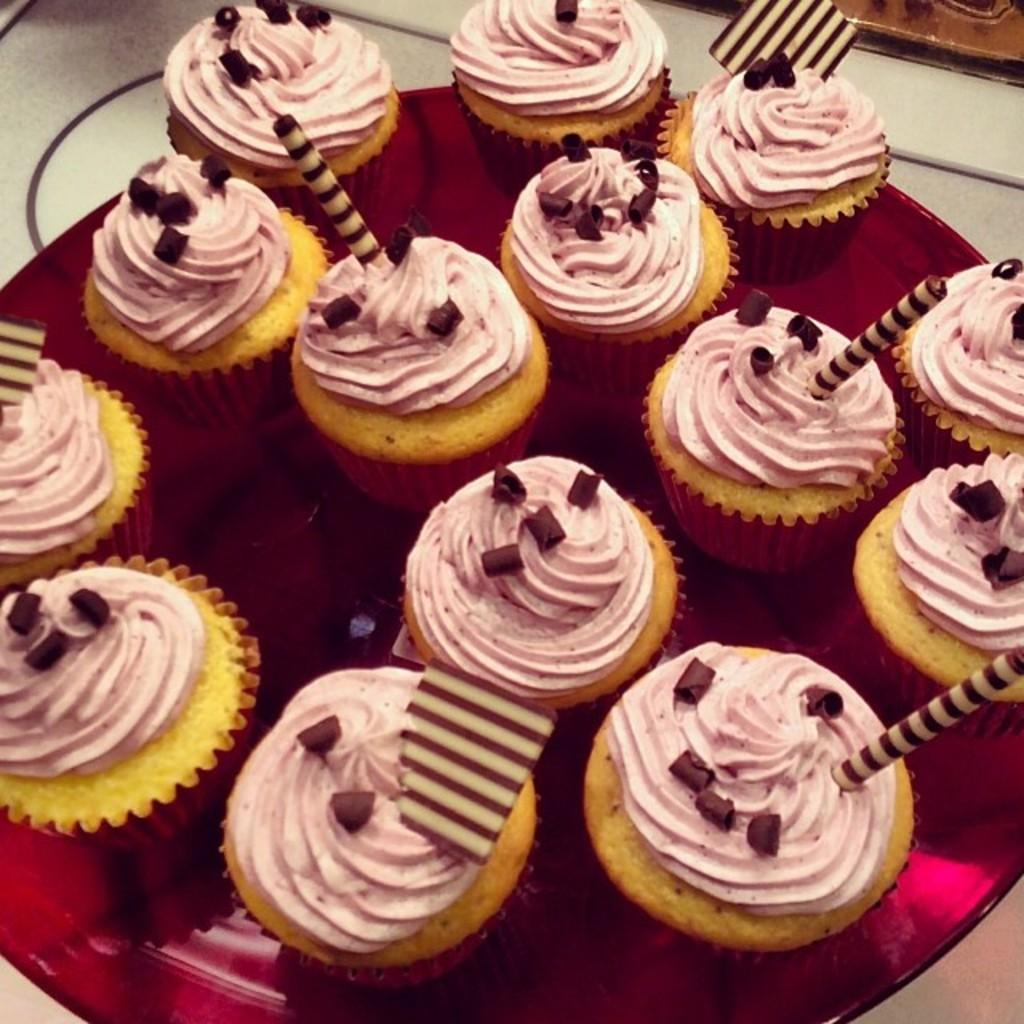What is on the surface in the image? There is a plate in the image. What is on the plate? There are cupcakes on the plate. Can you describe the surface on which the plate is placed? The plate is on a surface, but the specific type of surface is not mentioned in the facts. How many representatives are present in the image? There is no mention of representatives in the image; it features a plate with cupcakes on a surface. 